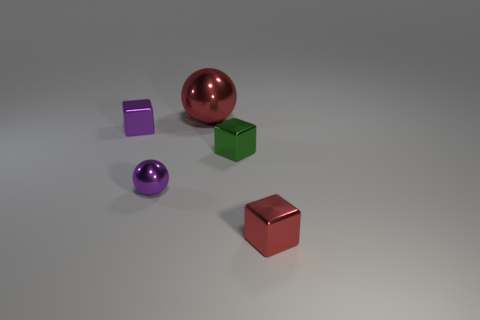Add 4 purple things. How many objects exist? 9 Subtract all spheres. How many objects are left? 3 Subtract 1 red cubes. How many objects are left? 4 Subtract all green metallic objects. Subtract all purple shiny things. How many objects are left? 2 Add 5 red objects. How many red objects are left? 7 Add 5 red shiny blocks. How many red shiny blocks exist? 6 